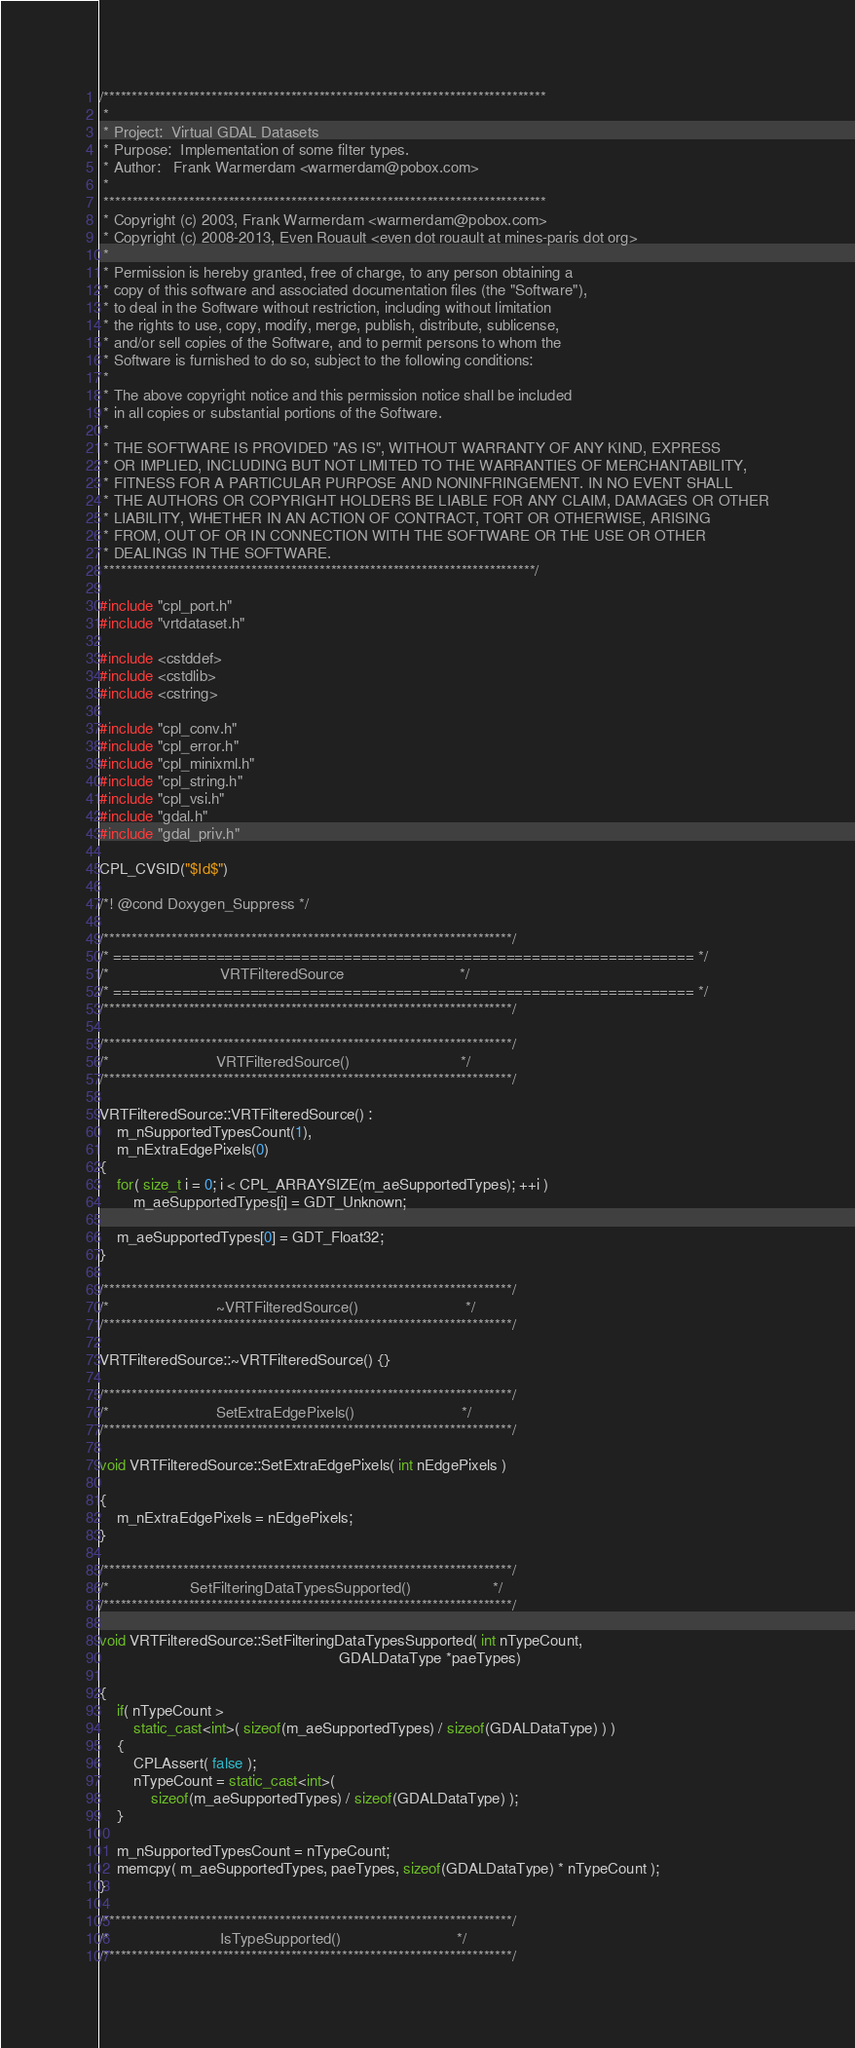<code> <loc_0><loc_0><loc_500><loc_500><_C++_>/******************************************************************************
 *
 * Project:  Virtual GDAL Datasets
 * Purpose:  Implementation of some filter types.
 * Author:   Frank Warmerdam <warmerdam@pobox.com>
 *
 ******************************************************************************
 * Copyright (c) 2003, Frank Warmerdam <warmerdam@pobox.com>
 * Copyright (c) 2008-2013, Even Rouault <even dot rouault at mines-paris dot org>
 *
 * Permission is hereby granted, free of charge, to any person obtaining a
 * copy of this software and associated documentation files (the "Software"),
 * to deal in the Software without restriction, including without limitation
 * the rights to use, copy, modify, merge, publish, distribute, sublicense,
 * and/or sell copies of the Software, and to permit persons to whom the
 * Software is furnished to do so, subject to the following conditions:
 *
 * The above copyright notice and this permission notice shall be included
 * in all copies or substantial portions of the Software.
 *
 * THE SOFTWARE IS PROVIDED "AS IS", WITHOUT WARRANTY OF ANY KIND, EXPRESS
 * OR IMPLIED, INCLUDING BUT NOT LIMITED TO THE WARRANTIES OF MERCHANTABILITY,
 * FITNESS FOR A PARTICULAR PURPOSE AND NONINFRINGEMENT. IN NO EVENT SHALL
 * THE AUTHORS OR COPYRIGHT HOLDERS BE LIABLE FOR ANY CLAIM, DAMAGES OR OTHER
 * LIABILITY, WHETHER IN AN ACTION OF CONTRACT, TORT OR OTHERWISE, ARISING
 * FROM, OUT OF OR IN CONNECTION WITH THE SOFTWARE OR THE USE OR OTHER
 * DEALINGS IN THE SOFTWARE.
 ****************************************************************************/

#include "cpl_port.h"
#include "vrtdataset.h"

#include <cstddef>
#include <cstdlib>
#include <cstring>

#include "cpl_conv.h"
#include "cpl_error.h"
#include "cpl_minixml.h"
#include "cpl_string.h"
#include "cpl_vsi.h"
#include "gdal.h"
#include "gdal_priv.h"

CPL_CVSID("$Id$")

/*! @cond Doxygen_Suppress */

/************************************************************************/
/* ==================================================================== */
/*                          VRTFilteredSource                           */
/* ==================================================================== */
/************************************************************************/

/************************************************************************/
/*                         VRTFilteredSource()                          */
/************************************************************************/

VRTFilteredSource::VRTFilteredSource() :
    m_nSupportedTypesCount(1),
    m_nExtraEdgePixels(0)
{
    for( size_t i = 0; i < CPL_ARRAYSIZE(m_aeSupportedTypes); ++i )
        m_aeSupportedTypes[i] = GDT_Unknown;

    m_aeSupportedTypes[0] = GDT_Float32;
}

/************************************************************************/
/*                         ~VRTFilteredSource()                         */
/************************************************************************/

VRTFilteredSource::~VRTFilteredSource() {}

/************************************************************************/
/*                         SetExtraEdgePixels()                         */
/************************************************************************/

void VRTFilteredSource::SetExtraEdgePixels( int nEdgePixels )

{
    m_nExtraEdgePixels = nEdgePixels;
}

/************************************************************************/
/*                   SetFilteringDataTypesSupported()                   */
/************************************************************************/

void VRTFilteredSource::SetFilteringDataTypesSupported( int nTypeCount,
                                                        GDALDataType *paeTypes)

{
    if( nTypeCount >
        static_cast<int>( sizeof(m_aeSupportedTypes) / sizeof(GDALDataType) ) )
    {
        CPLAssert( false );
        nTypeCount = static_cast<int>(
            sizeof(m_aeSupportedTypes) / sizeof(GDALDataType) );
    }

    m_nSupportedTypesCount = nTypeCount;
    memcpy( m_aeSupportedTypes, paeTypes, sizeof(GDALDataType) * nTypeCount );
}

/************************************************************************/
/*                          IsTypeSupported()                           */
/************************************************************************/
</code> 